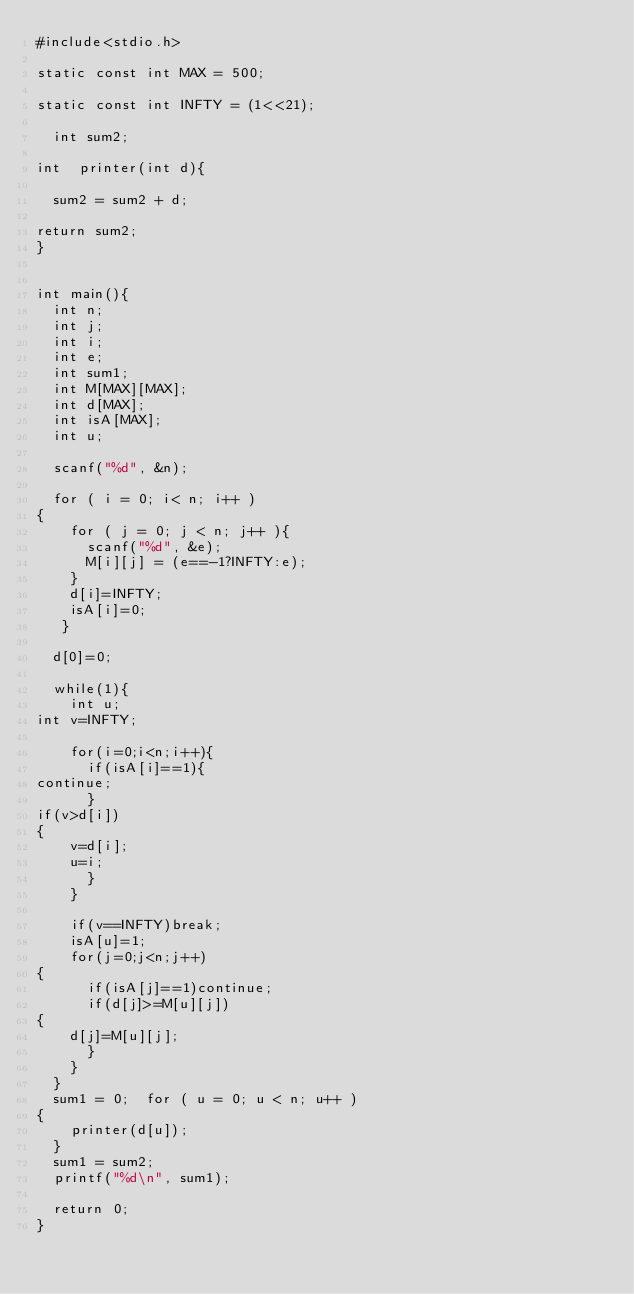<code> <loc_0><loc_0><loc_500><loc_500><_C_>#include<stdio.h>
 
static const int MAX = 500;

static const int INFTY = (1<<21);
  
  int sum2;

int  printer(int d){

  sum2 = sum2 + d;
  
return sum2;
}
 

int main(){
  int n;
  int j;
  int i;
  int e;
  int sum1;
  int M[MAX][MAX];
  int d[MAX];
  int isA[MAX];
  int u;
   
  scanf("%d", &n);
   
  for ( i = 0; i< n; i++ )
{
    for ( j = 0; j < n; j++ ){
      scanf("%d", &e);
      M[i][j] = (e==-1?INFTY:e);
    }   
    d[i]=INFTY;
    isA[i]=0;
   }
   
  d[0]=0;
 
  while(1){
    int u;
int v=INFTY;
     
    for(i=0;i<n;i++){
      if(isA[i]==1){
continue;
      }      
if(v>d[i])
{
    v=d[i];
    u=i;
      }
    }
 
    if(v==INFTY)break;
    isA[u]=1;
    for(j=0;j<n;j++)
{
      if(isA[j]==1)continue;
      if(d[j]>=M[u][j])
{
    d[j]=M[u][j];
      }
    }
  } 
  sum1 = 0;  for ( u = 0; u < n; u++ )
{
    printer(d[u]);
  }
  sum1 = sum2;
  printf("%d\n", sum1);
   
  return 0;
}</code> 